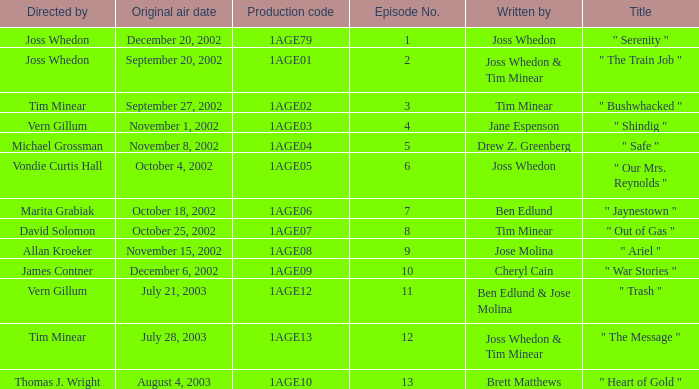Who directed episode number 3? Tim Minear. 